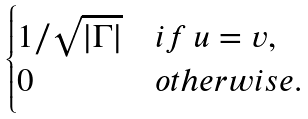Convert formula to latex. <formula><loc_0><loc_0><loc_500><loc_500>\begin{cases} 1 / \sqrt { | \Gamma | } & i f \, u = v , \\ 0 & o t h e r w i s e . \end{cases}</formula> 